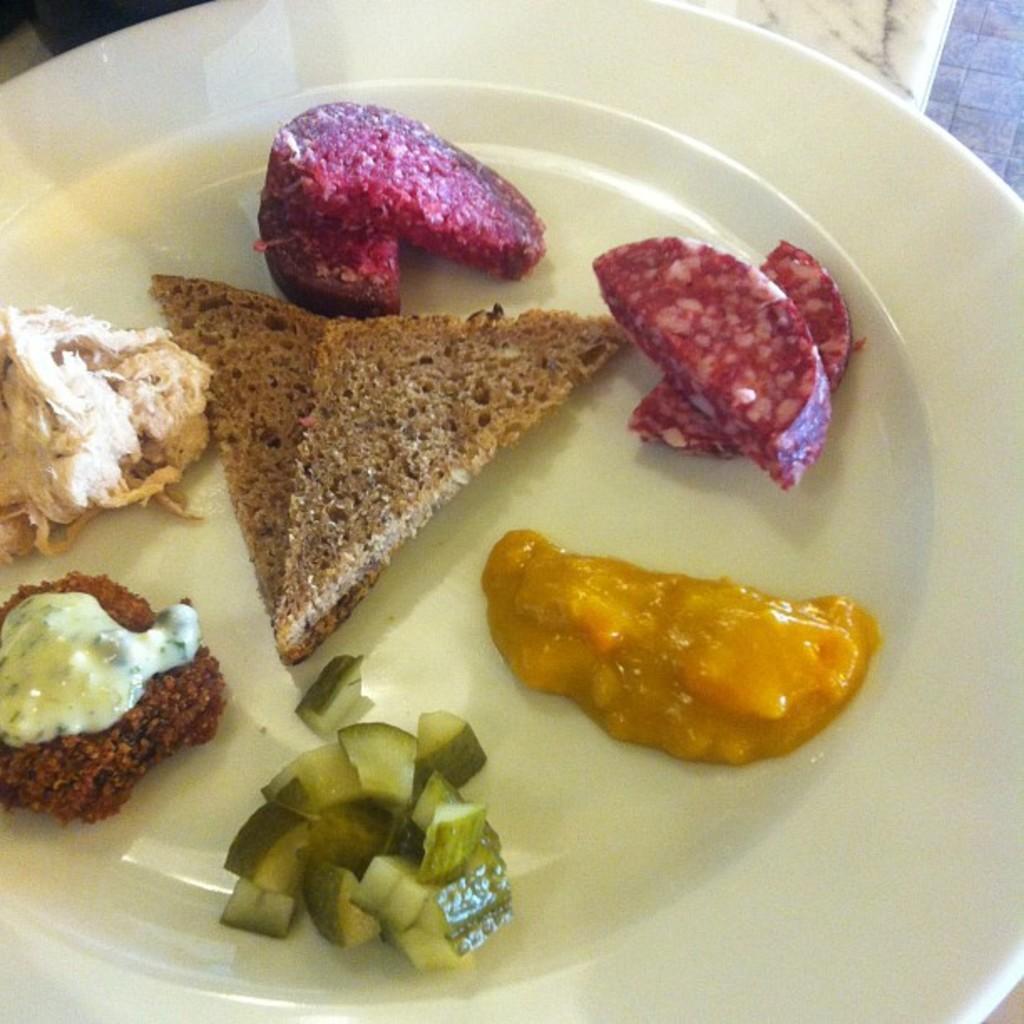In one or two sentences, can you explain what this image depicts? There are some food items kept on a plate like bread slices, cucumber and some other creams. 